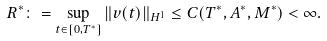<formula> <loc_0><loc_0><loc_500><loc_500>R ^ { * } \colon = \sup _ { t \in [ 0 , T ^ { * } ] } \| v ( t ) \| _ { H ^ { 1 } } \leq C ( T ^ { * } , A ^ { * } , M ^ { * } ) < \infty .</formula> 